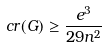Convert formula to latex. <formula><loc_0><loc_0><loc_500><loc_500>c r ( G ) \geq \frac { e ^ { 3 } } { 2 9 n ^ { 2 } }</formula> 